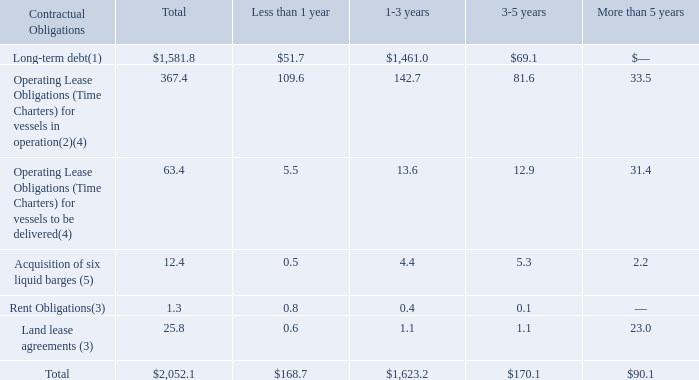F. Contractual Obligations as at December 31, 2019:
Payment due by period ($ in millions) (unaudited)
(1) The amount identified does not include interest costs associated with the outstanding credit facilities, which are based on LIBOR rates, plus the costs of complying with any applicable regulatory requirements and a margin ranging from 2.75% to 3.25% per annum. The amount does not include interest costs for the 2022 Senior Secured Notes, the 2022 Notes, the 2024 Notes, the NSM Loan, the 2022 Logistics Senior Notes, the Term Loan B Facility and the Navios Logistics Notes Payable. The expected interest payments are: $127.8 million (less than 1 year), $166.6 million (1-3 years), $3.8 million (3-5 years) and nil (more than 5 years). Expected interest payments are based on outstanding principal amounts, currently applicable effective interest rates and margins as of December 31, 2019, timing of scheduled payments and the term of the debt obligations.
(2) Approximately 41% of the time charter payments included above is estimated to relate to operational costs for these vessels.
(3) Navios Logistics has several lease agreements with respect to its operating port terminals and various offices. Following the sale of the management division effected on August 30, 2019 Navios Holdings has no office lease obligations (see also Note 16 included elsewhere in this Annual Report). See also Item 4.B. “Business Overview — Facilities.”
(4) Represent total amount of lease payments on an undiscounted basis.
(5) Represents principal payments of the future remaining obligation for the acquisition of six liquid barges, which bear interest at fixed rate. The amounts in the table exclude expected interest payments of $0.3 million (less than 1 year), $1.8 million (1-3 years), $0.9 million (3-5 years) and 0.1 million (more than 5 years). Expected interest payments are based on the terms of the shipbuilding contract for the construction of these barges.
What percentage of the time charter payments for Operating Lease Obligations (Time Charters) for vessels in operation were estimated to relate to operational costs for the company's vessels?
Answer scale should be: percent. 41. What was the total long-term debt?
Answer scale should be: million. 1,581.8. What were the total Rent Obligations?
Answer scale should be: million. 1.3. What was the difference between the total rent obligations and land lease agreements?
Answer scale should be: million. 25.8-1.3
Answer: 24.5. What was the difference between the total Acquisition of six liquid barges and long-term debt? 
Answer scale should be: million. 1,581.8-12.4
Answer: 1569.4. What percentage of total contractual obligations were due less than a year?
Answer scale should be: percent. (168.7/2,052.1)
Answer: 8.22. 